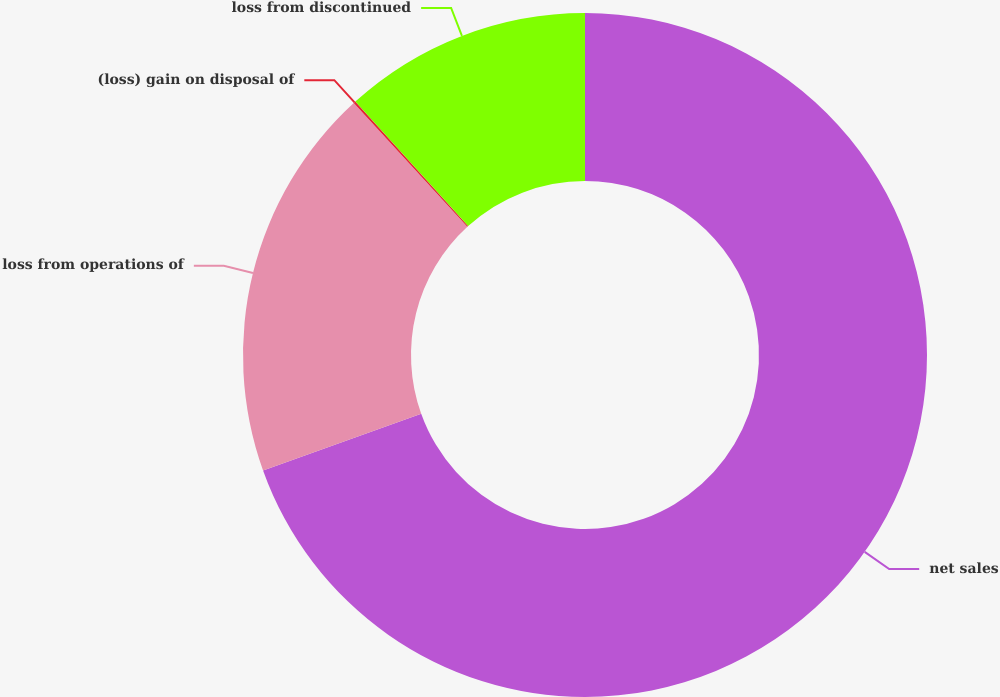Convert chart to OTSL. <chart><loc_0><loc_0><loc_500><loc_500><pie_chart><fcel>net sales<fcel>loss from operations of<fcel>(loss) gain on disposal of<fcel>loss from discontinued<nl><fcel>69.53%<fcel>18.66%<fcel>0.1%<fcel>11.72%<nl></chart> 